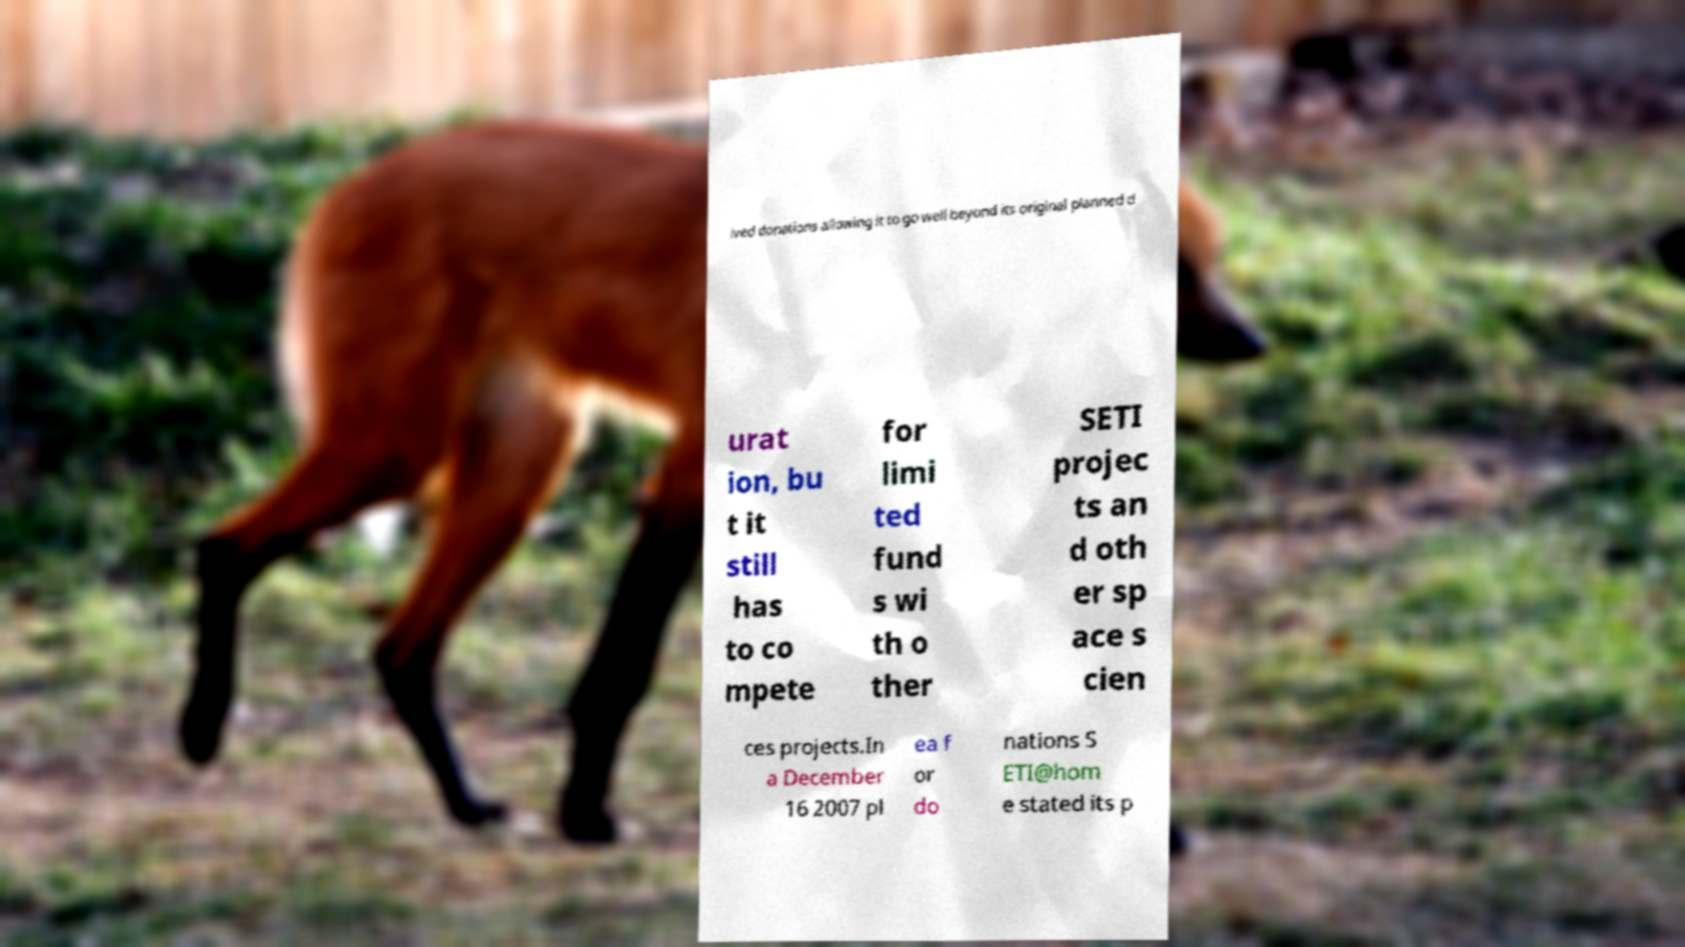Can you read and provide the text displayed in the image?This photo seems to have some interesting text. Can you extract and type it out for me? ived donations allowing it to go well beyond its original planned d urat ion, bu t it still has to co mpete for limi ted fund s wi th o ther SETI projec ts an d oth er sp ace s cien ces projects.In a December 16 2007 pl ea f or do nations S ETI@hom e stated its p 